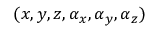Convert formula to latex. <formula><loc_0><loc_0><loc_500><loc_500>( x , y , z , \alpha _ { x } , \alpha _ { y } , \alpha _ { z } )</formula> 